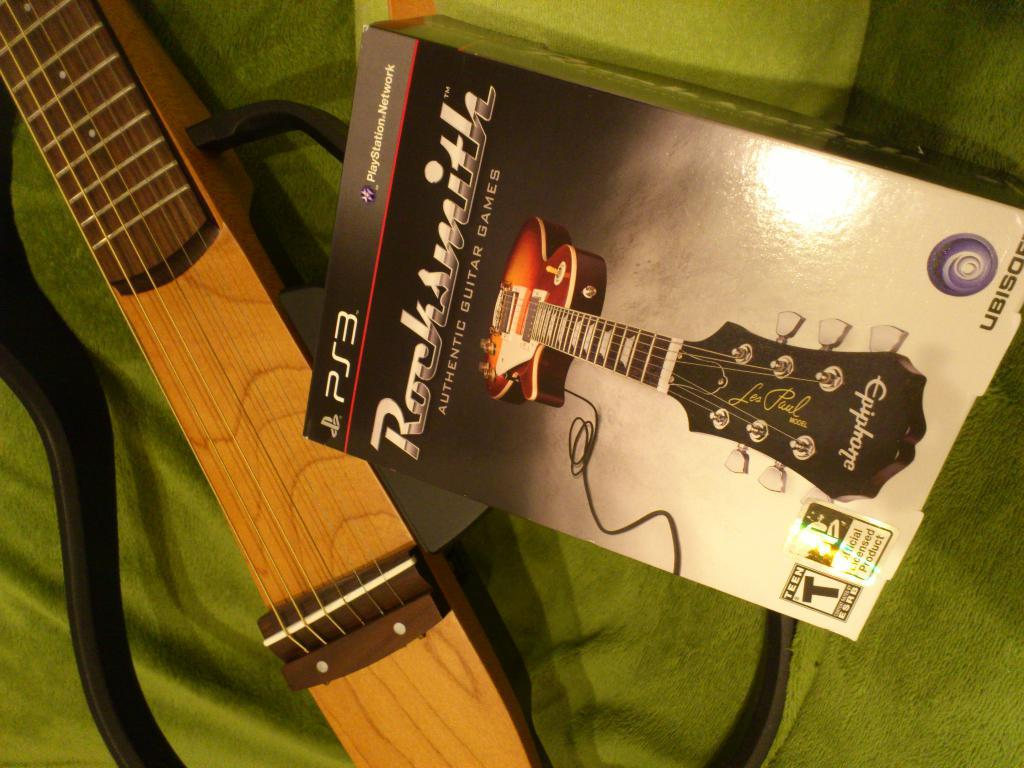<image>
Summarize the visual content of the image. The PS3 game Rocksmith is sitting on a green blanket next to a guitar 